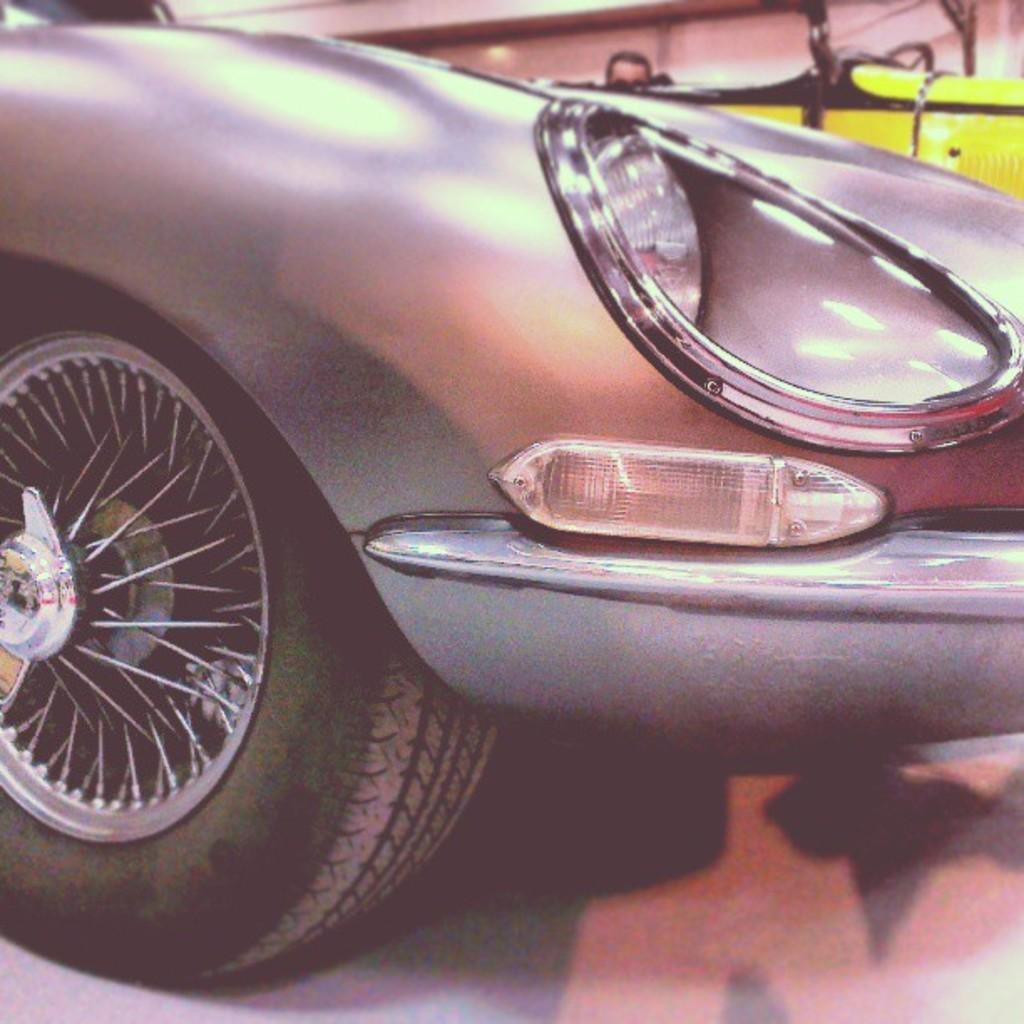Could you give a brief overview of what you see in this image? In this image I see a car which is silver in color and in the background I see the yellow color thing over here and I see a person's head over here. 